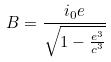<formula> <loc_0><loc_0><loc_500><loc_500>B = \frac { i _ { 0 } e } { \sqrt { 1 - \frac { e ^ { 3 } } { c ^ { 3 } } } }</formula> 